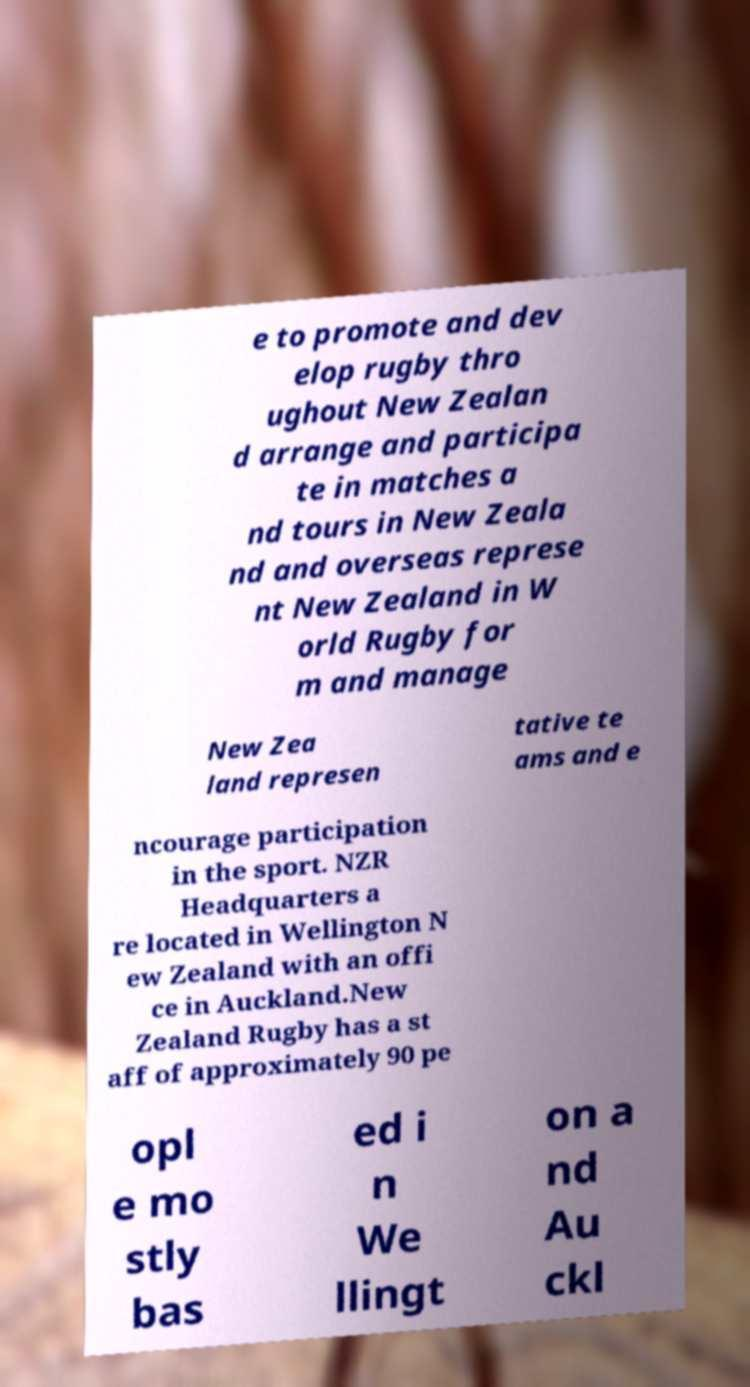Please read and relay the text visible in this image. What does it say? e to promote and dev elop rugby thro ughout New Zealan d arrange and participa te in matches a nd tours in New Zeala nd and overseas represe nt New Zealand in W orld Rugby for m and manage New Zea land represen tative te ams and e ncourage participation in the sport. NZR Headquarters a re located in Wellington N ew Zealand with an offi ce in Auckland.New Zealand Rugby has a st aff of approximately 90 pe opl e mo stly bas ed i n We llingt on a nd Au ckl 